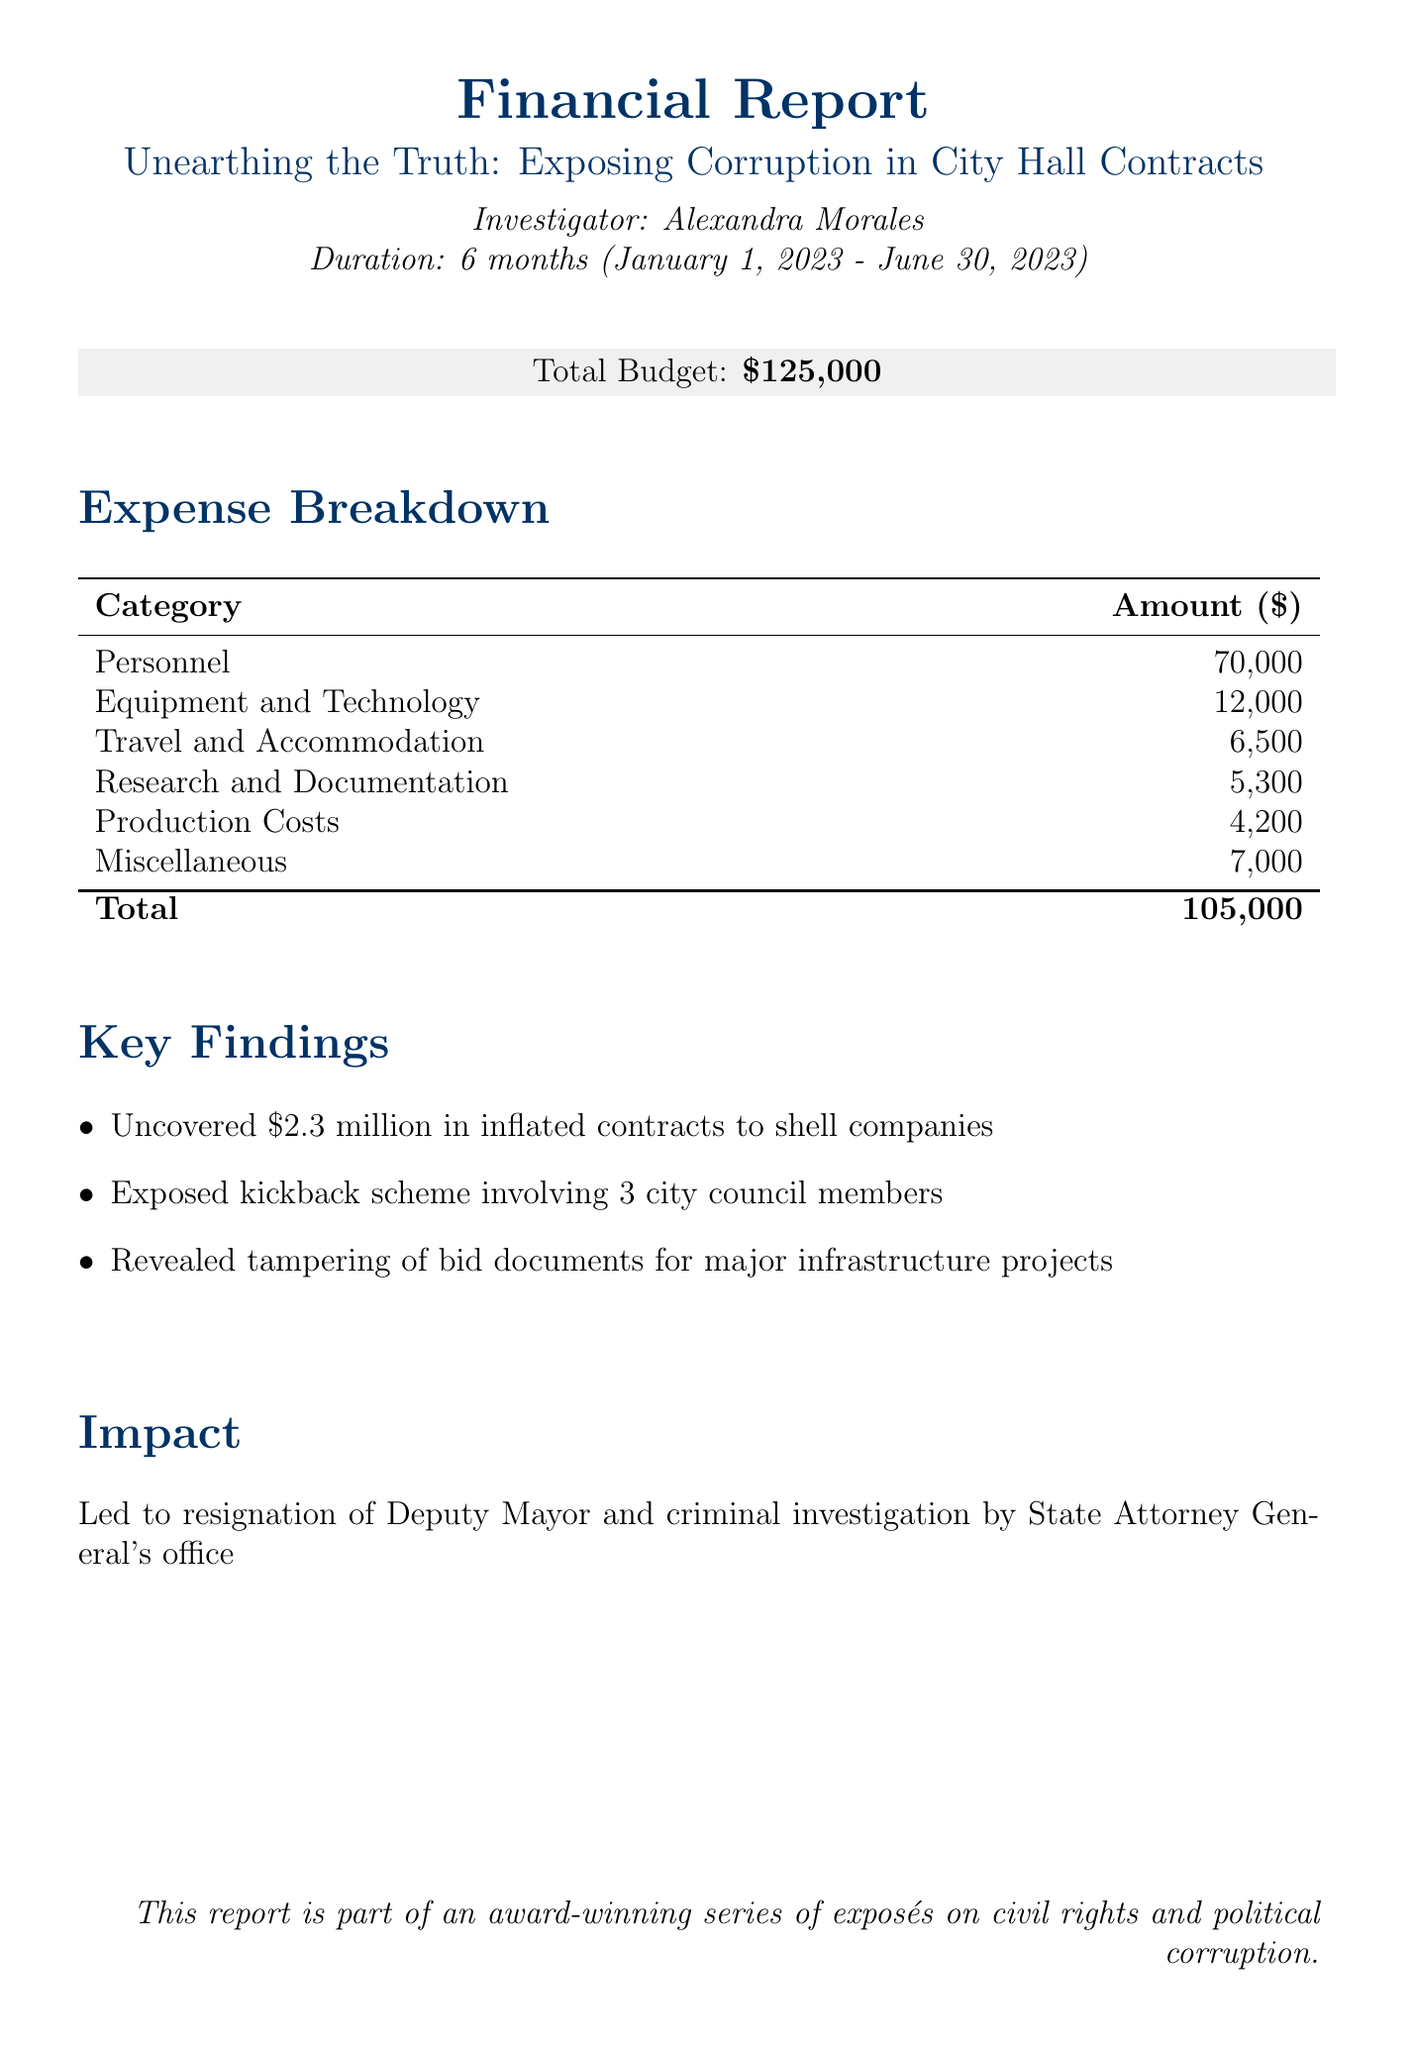What is the project title? The project title is explicitly stated at the beginning of the report.
Answer: Unearthing the Truth: Exposing Corruption in City Hall Contracts Who is the investigator? The investigator's name is mentioned right after the project title.
Answer: Alexandra Morales What is the total budget for the project? The document lists the total budget prominently.
Answer: $125,000 How much was spent on personnel? The expense breakdown details the total amount allocated for the personnel category.
Answer: $70,000 What were the hotel stays for out-of-town interviews? The specific amount spent on hotel stays is provided in the travel and accommodation expenses.
Answer: $4,000 Name one of the key findings of the investigation. The report enumerates key findings, listing them item by item.
Answer: Uncovered $2.3 million in inflated contracts to shell companies How much was spent on equipment and technology? The total spending on the equipment and technology category is stated in the expense breakdown.
Answer: $12,000 What was one of the impacts of the investigation? The document explains the outcome of the investigation under the impact section.
Answer: Led to resignation of Deputy Mayor How long was the duration of the project? The duration of the project is mentioned in the introductory section of the report.
Answer: 6 months (January 1, 2023 - June 30, 2023) 